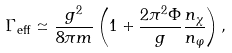<formula> <loc_0><loc_0><loc_500><loc_500>\Gamma _ { \text {eff} } \simeq \frac { g ^ { 2 } } { 8 \pi m } \left ( 1 + \frac { 2 \pi ^ { 2 } \Phi } { g } \frac { n _ { \chi } } { n _ { \varphi } } \right ) ,</formula> 